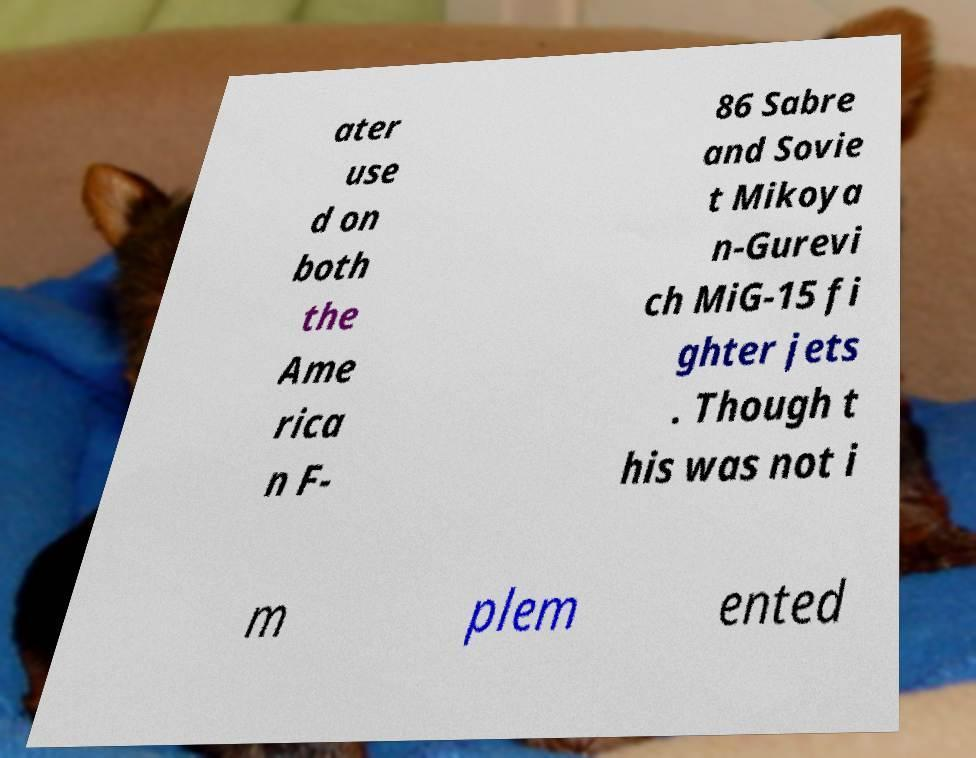Please identify and transcribe the text found in this image. ater use d on both the Ame rica n F- 86 Sabre and Sovie t Mikoya n-Gurevi ch MiG-15 fi ghter jets . Though t his was not i m plem ented 